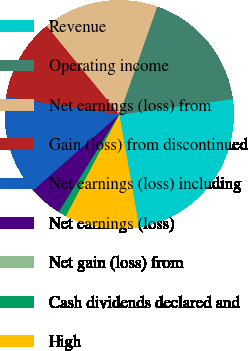Convert chart to OTSL. <chart><loc_0><loc_0><loc_500><loc_500><pie_chart><fcel>Revenue<fcel>Operating income<fcel>Net earnings (loss) from<fcel>Gain (loss) from discontinued<fcel>Net earnings (loss) including<fcel>Net earnings (loss)<fcel>Net gain (loss) from<fcel>Cash dividends declared and<fcel>High<nl><fcel>24.42%<fcel>17.44%<fcel>16.28%<fcel>11.63%<fcel>13.95%<fcel>4.65%<fcel>0.0%<fcel>1.16%<fcel>10.47%<nl></chart> 